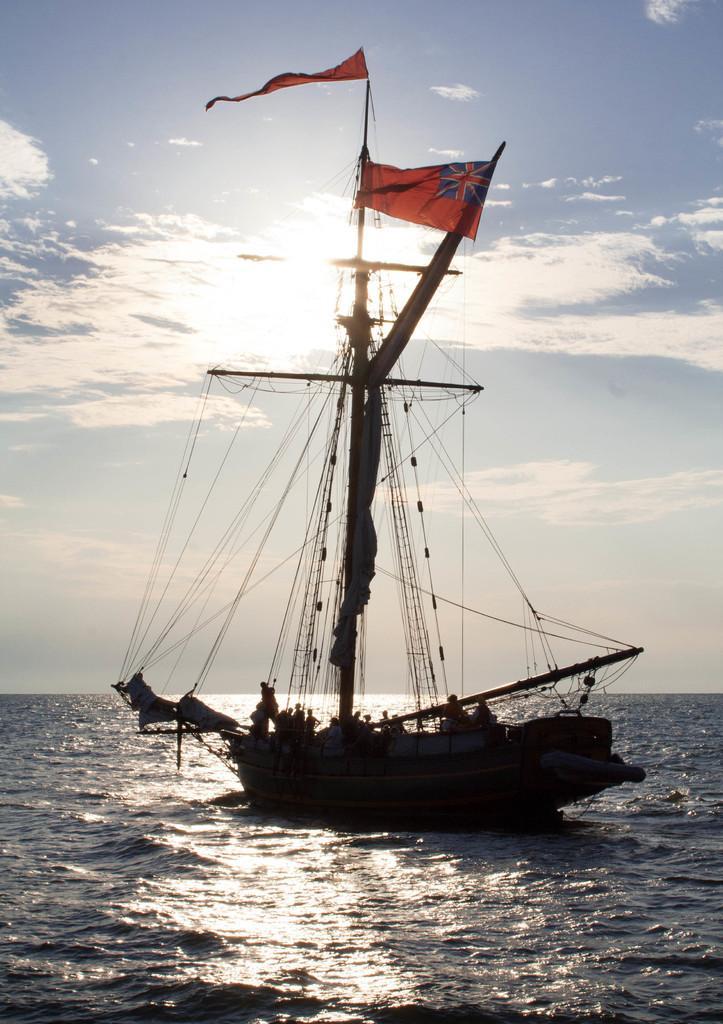Describe this image in one or two sentences. There is a boat in the water. On the boat there are poles, ropes and flags. Some people are there in the boat. In the background there is sky. 